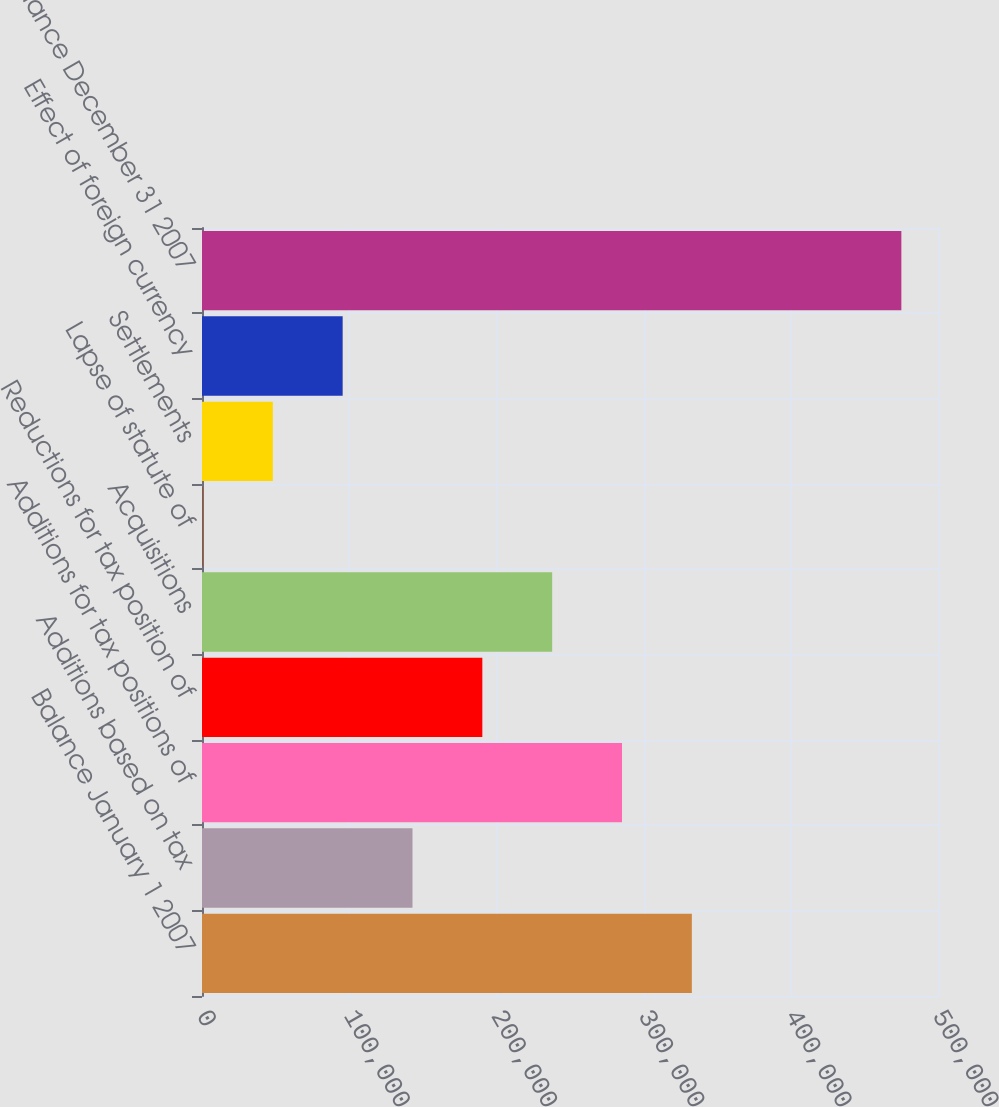Convert chart to OTSL. <chart><loc_0><loc_0><loc_500><loc_500><bar_chart><fcel>Balance January 1 2007<fcel>Additions based on tax<fcel>Additions for tax positions of<fcel>Reductions for tax position of<fcel>Acquisitions<fcel>Lapse of statute of<fcel>Settlements<fcel>Effect of foreign currency<fcel>Balance December 31 2007<nl><fcel>332777<fcel>143003<fcel>285333<fcel>190447<fcel>237890<fcel>673<fcel>48116.4<fcel>95559.8<fcel>475107<nl></chart> 